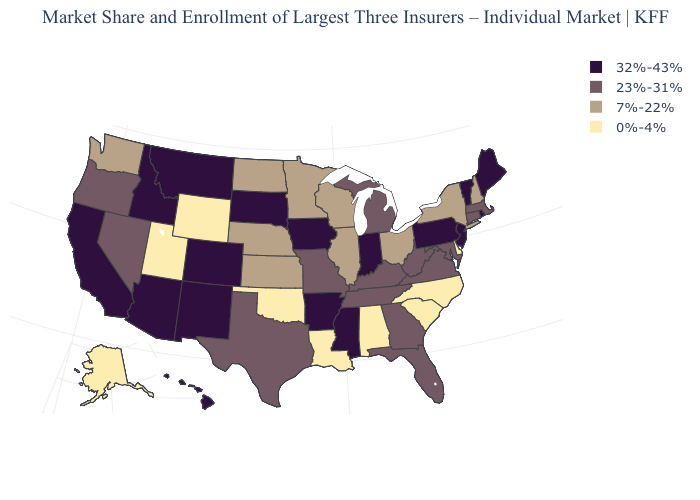What is the highest value in states that border California?
Give a very brief answer. 32%-43%. What is the highest value in the USA?
Answer briefly. 32%-43%. How many symbols are there in the legend?
Give a very brief answer. 4. What is the lowest value in states that border Indiana?
Answer briefly. 7%-22%. Name the states that have a value in the range 7%-22%?
Short answer required. Illinois, Kansas, Minnesota, Nebraska, New Hampshire, New York, North Dakota, Ohio, Washington, Wisconsin. What is the value of Iowa?
Concise answer only. 32%-43%. Which states have the highest value in the USA?
Quick response, please. Arizona, Arkansas, California, Colorado, Hawaii, Idaho, Indiana, Iowa, Maine, Mississippi, Montana, New Jersey, New Mexico, Pennsylvania, Rhode Island, South Dakota, Vermont. Which states hav the highest value in the West?
Quick response, please. Arizona, California, Colorado, Hawaii, Idaho, Montana, New Mexico. Does Arkansas have the highest value in the South?
Short answer required. Yes. How many symbols are there in the legend?
Be succinct. 4. What is the highest value in states that border Wisconsin?
Keep it brief. 32%-43%. Does New York have a higher value than Alaska?
Keep it brief. Yes. What is the value of Maine?
Write a very short answer. 32%-43%. What is the value of Texas?
Keep it brief. 23%-31%. What is the lowest value in the West?
Concise answer only. 0%-4%. 